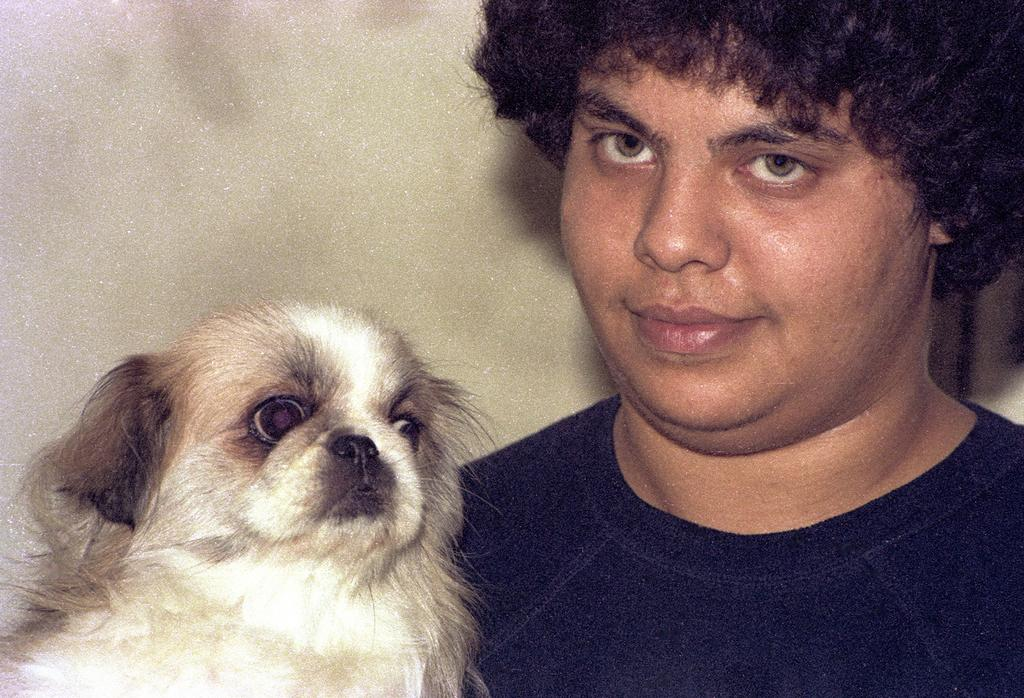What is the main subject in the image? There is a man in the image. Are there any other living beings present in the image? Yes, there is a dog in the image. What type of engine can be seen in the image? There is no engine present in the image. What type of fowl is visible in the image? There is no fowl present in the image. Where is the faucet located in the image? There is no faucet present in the image. 